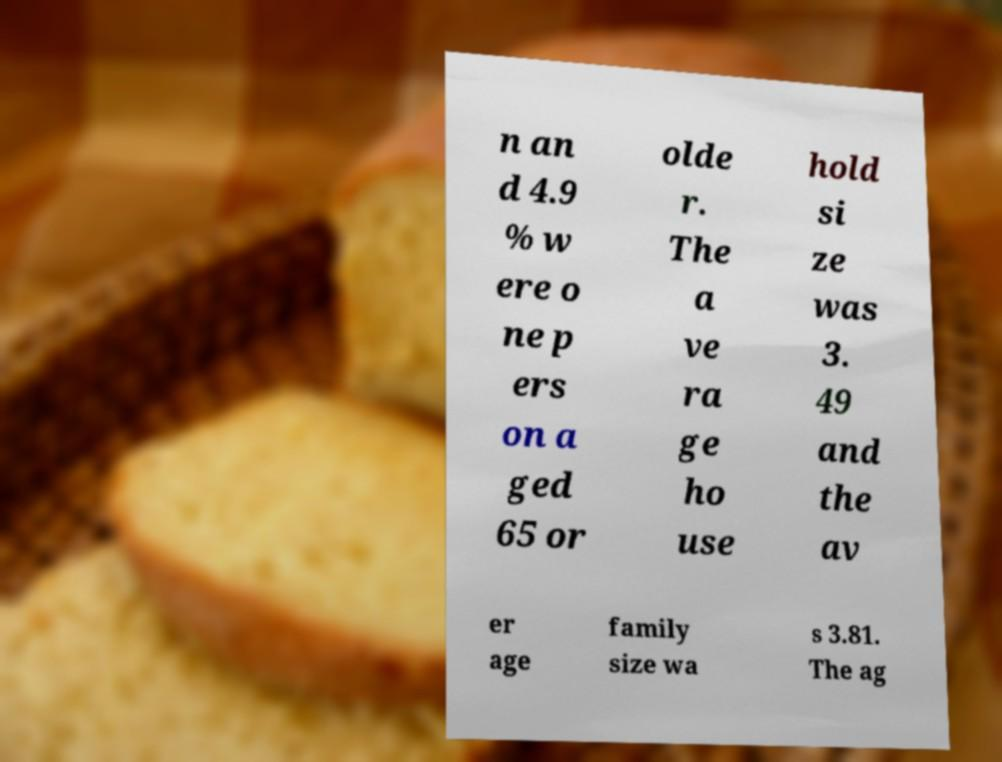Can you accurately transcribe the text from the provided image for me? n an d 4.9 % w ere o ne p ers on a ged 65 or olde r. The a ve ra ge ho use hold si ze was 3. 49 and the av er age family size wa s 3.81. The ag 